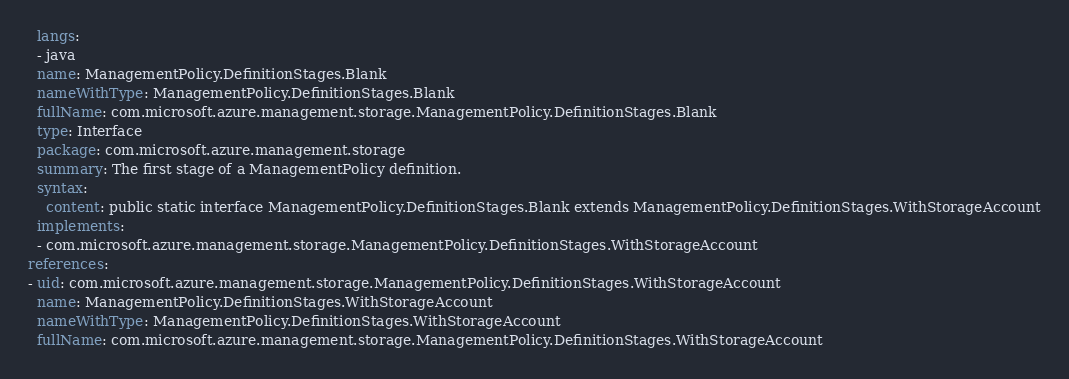<code> <loc_0><loc_0><loc_500><loc_500><_YAML_>  langs:
  - java
  name: ManagementPolicy.DefinitionStages.Blank
  nameWithType: ManagementPolicy.DefinitionStages.Blank
  fullName: com.microsoft.azure.management.storage.ManagementPolicy.DefinitionStages.Blank
  type: Interface
  package: com.microsoft.azure.management.storage
  summary: The first stage of a ManagementPolicy definition.
  syntax:
    content: public static interface ManagementPolicy.DefinitionStages.Blank extends ManagementPolicy.DefinitionStages.WithStorageAccount
  implements:
  - com.microsoft.azure.management.storage.ManagementPolicy.DefinitionStages.WithStorageAccount
references:
- uid: com.microsoft.azure.management.storage.ManagementPolicy.DefinitionStages.WithStorageAccount
  name: ManagementPolicy.DefinitionStages.WithStorageAccount
  nameWithType: ManagementPolicy.DefinitionStages.WithStorageAccount
  fullName: com.microsoft.azure.management.storage.ManagementPolicy.DefinitionStages.WithStorageAccount
</code> 